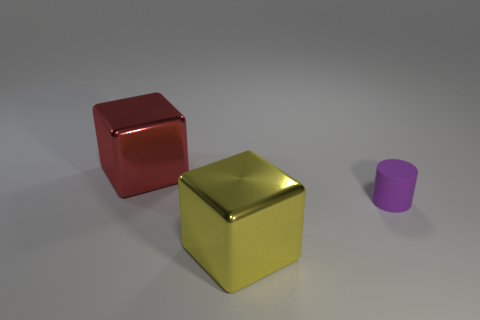Subtract all blocks. How many objects are left? 1 Add 2 large red things. How many objects exist? 5 Subtract all yellow blocks. How many blocks are left? 1 Subtract 2 cubes. How many cubes are left? 0 Subtract all cyan cylinders. Subtract all brown cubes. How many cylinders are left? 1 Subtract all big red matte blocks. Subtract all metal blocks. How many objects are left? 1 Add 2 big red metal blocks. How many big red metal blocks are left? 3 Add 3 big purple things. How many big purple things exist? 3 Subtract 1 red cubes. How many objects are left? 2 